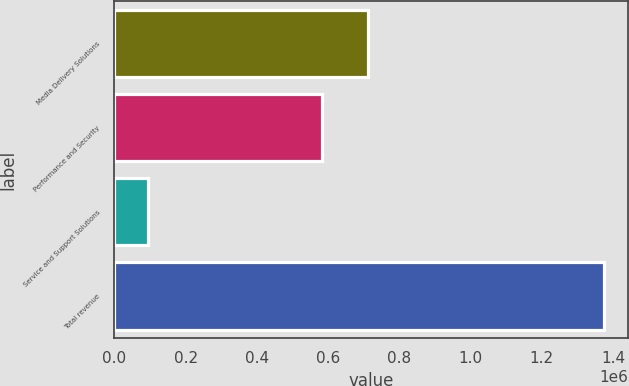<chart> <loc_0><loc_0><loc_500><loc_500><bar_chart><fcel>Media Delivery Solutions<fcel>Performance and Security<fcel>Service and Support Solutions<fcel>Total revenue<nl><fcel>711830<fcel>583818<fcel>93830<fcel>1.37395e+06<nl></chart> 